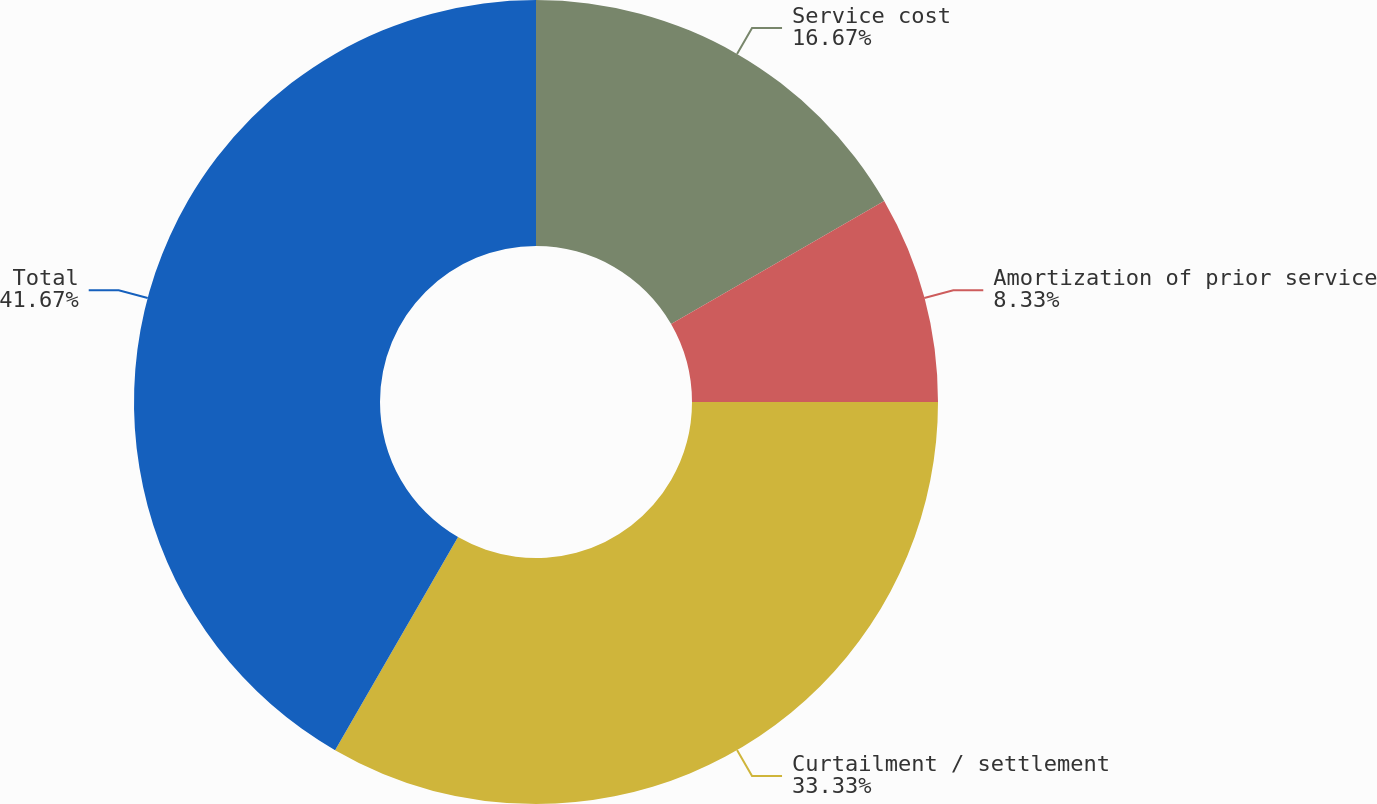<chart> <loc_0><loc_0><loc_500><loc_500><pie_chart><fcel>Service cost<fcel>Amortization of prior service<fcel>Curtailment / settlement<fcel>Total<nl><fcel>16.67%<fcel>8.33%<fcel>33.33%<fcel>41.67%<nl></chart> 